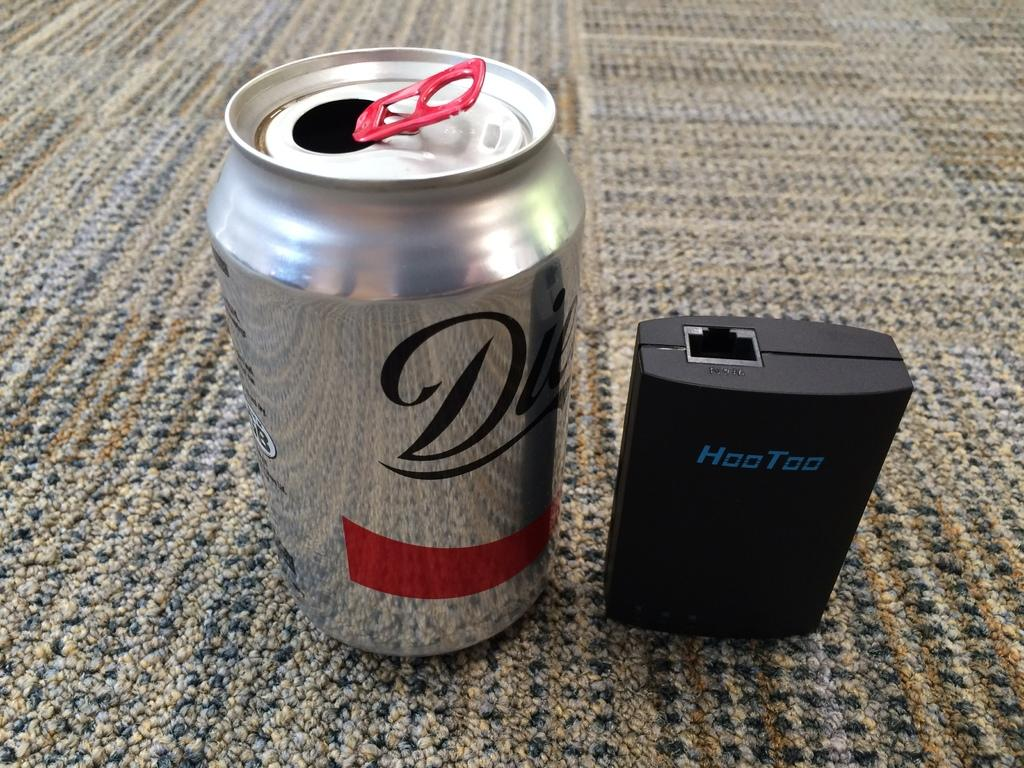<image>
Write a terse but informative summary of the picture. Silver can of beer that has the letter D on it next to a device that says HooToo. 